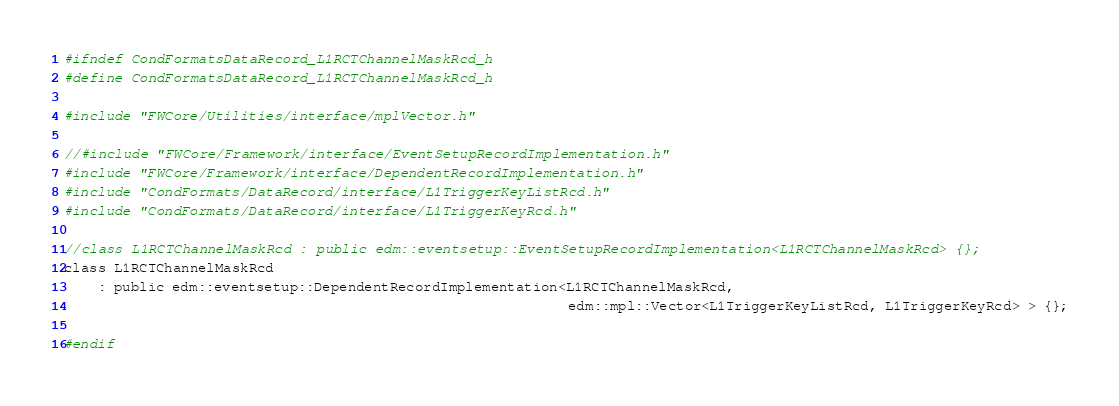Convert code to text. <code><loc_0><loc_0><loc_500><loc_500><_C_>#ifndef CondFormatsDataRecord_L1RCTChannelMaskRcd_h
#define CondFormatsDataRecord_L1RCTChannelMaskRcd_h

#include "FWCore/Utilities/interface/mplVector.h"

//#include "FWCore/Framework/interface/EventSetupRecordImplementation.h"
#include "FWCore/Framework/interface/DependentRecordImplementation.h"
#include "CondFormats/DataRecord/interface/L1TriggerKeyListRcd.h"
#include "CondFormats/DataRecord/interface/L1TriggerKeyRcd.h"

//class L1RCTChannelMaskRcd : public edm::eventsetup::EventSetupRecordImplementation<L1RCTChannelMaskRcd> {};
class L1RCTChannelMaskRcd
    : public edm::eventsetup::DependentRecordImplementation<L1RCTChannelMaskRcd,
                                                            edm::mpl::Vector<L1TriggerKeyListRcd, L1TriggerKeyRcd> > {};

#endif
</code> 